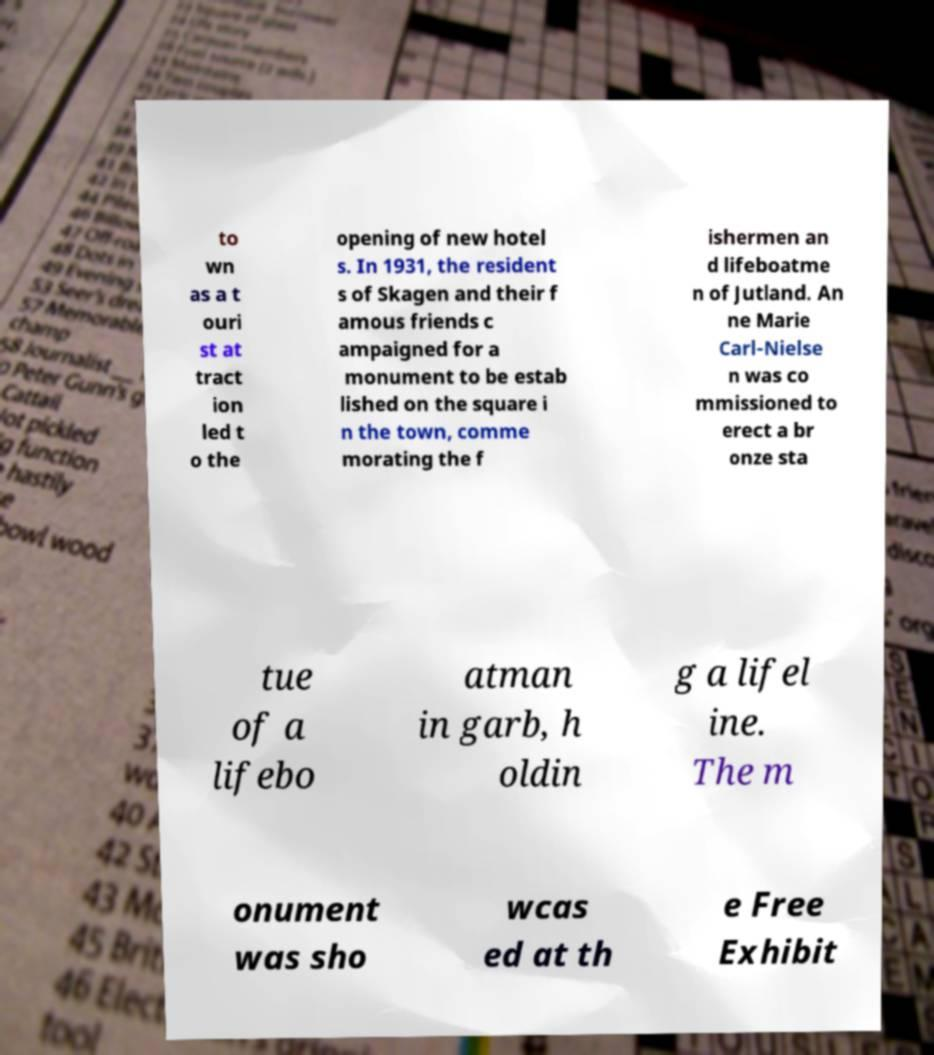Please identify and transcribe the text found in this image. to wn as a t ouri st at tract ion led t o the opening of new hotel s. In 1931, the resident s of Skagen and their f amous friends c ampaigned for a monument to be estab lished on the square i n the town, comme morating the f ishermen an d lifeboatme n of Jutland. An ne Marie Carl-Nielse n was co mmissioned to erect a br onze sta tue of a lifebo atman in garb, h oldin g a lifel ine. The m onument was sho wcas ed at th e Free Exhibit 